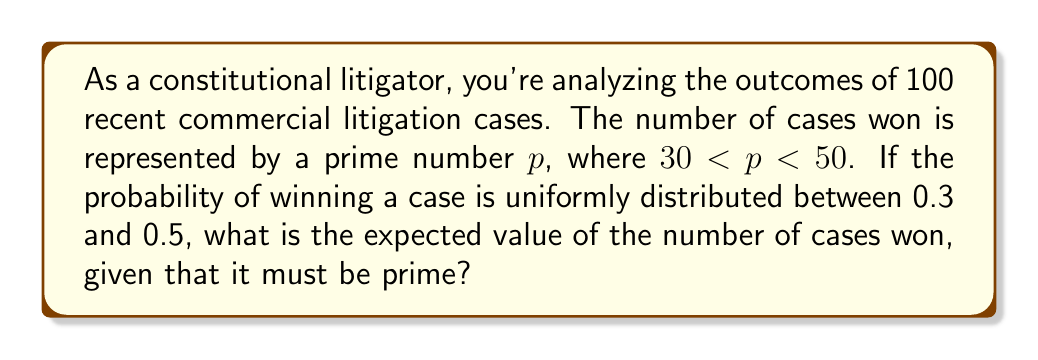Solve this math problem. Let's approach this step-by-step:

1) First, we need to identify the prime numbers between 30 and 50:
   31, 37, 41, 43, 47

2) Now, we need to calculate the probability of each of these outcomes, given the uniform distribution between 0.3 and 0.5:

   $P(X = k) = \frac{1}{0.5 - 0.3} = 5$ for $0.3 \leq \frac{k}{100} \leq 0.5$

3) For each prime $p$ in our range:
   $P(X = p | X \text{ is prime}) = \frac{P(X = p)}{\sum_{i \in \text{primes}} P(X = i)}$

4) The sum of probabilities for all primes in range:
   $\sum_{i \in \text{primes}} P(X = i) = 5 \times 5 = 25$

5) So, for each prime $p$:
   $P(X = p | X \text{ is prime}) = \frac{5}{25} = \frac{1}{5}$

6) The expected value is:

   $E(X | X \text{ is prime}) = \sum_{p \in \text{primes}} p \cdot P(X = p | X \text{ is prime})$

   $= \frac{1}{5}(31 + 37 + 41 + 43 + 47)$

   $= \frac{199}{5}$

   $= 39.8$

Therefore, the expected value of the number of cases won, given that it must be prime, is 39.8.
Answer: 39.8 